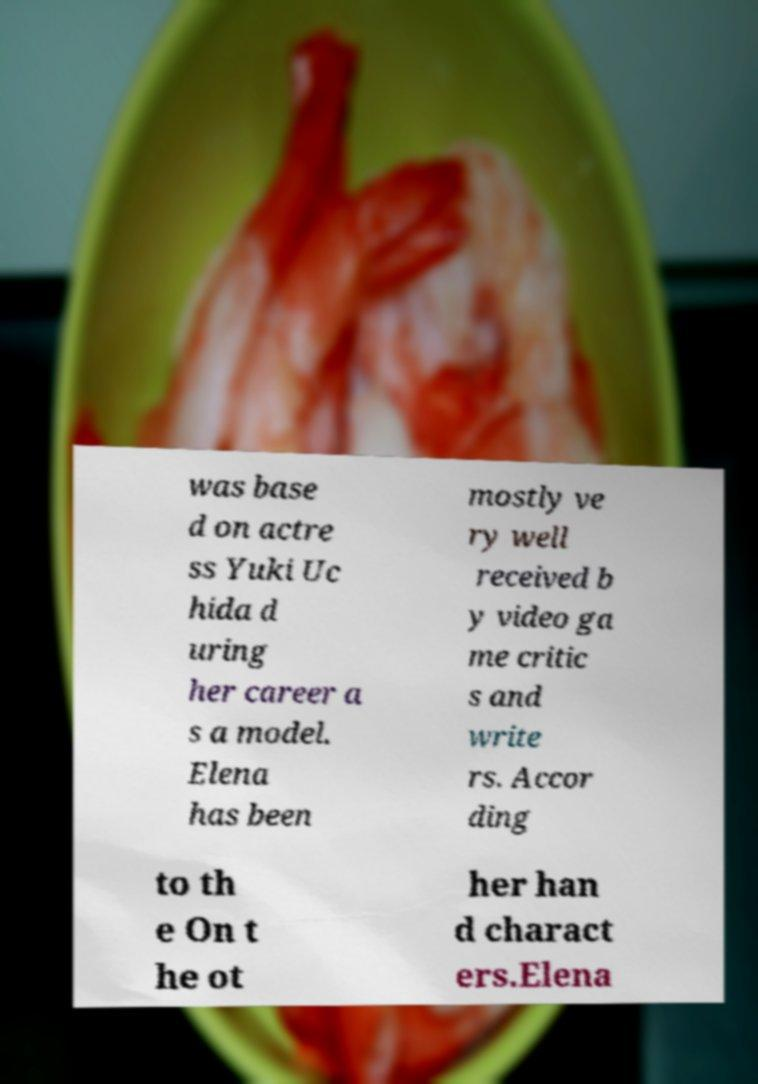Can you read and provide the text displayed in the image?This photo seems to have some interesting text. Can you extract and type it out for me? was base d on actre ss Yuki Uc hida d uring her career a s a model. Elena has been mostly ve ry well received b y video ga me critic s and write rs. Accor ding to th e On t he ot her han d charact ers.Elena 